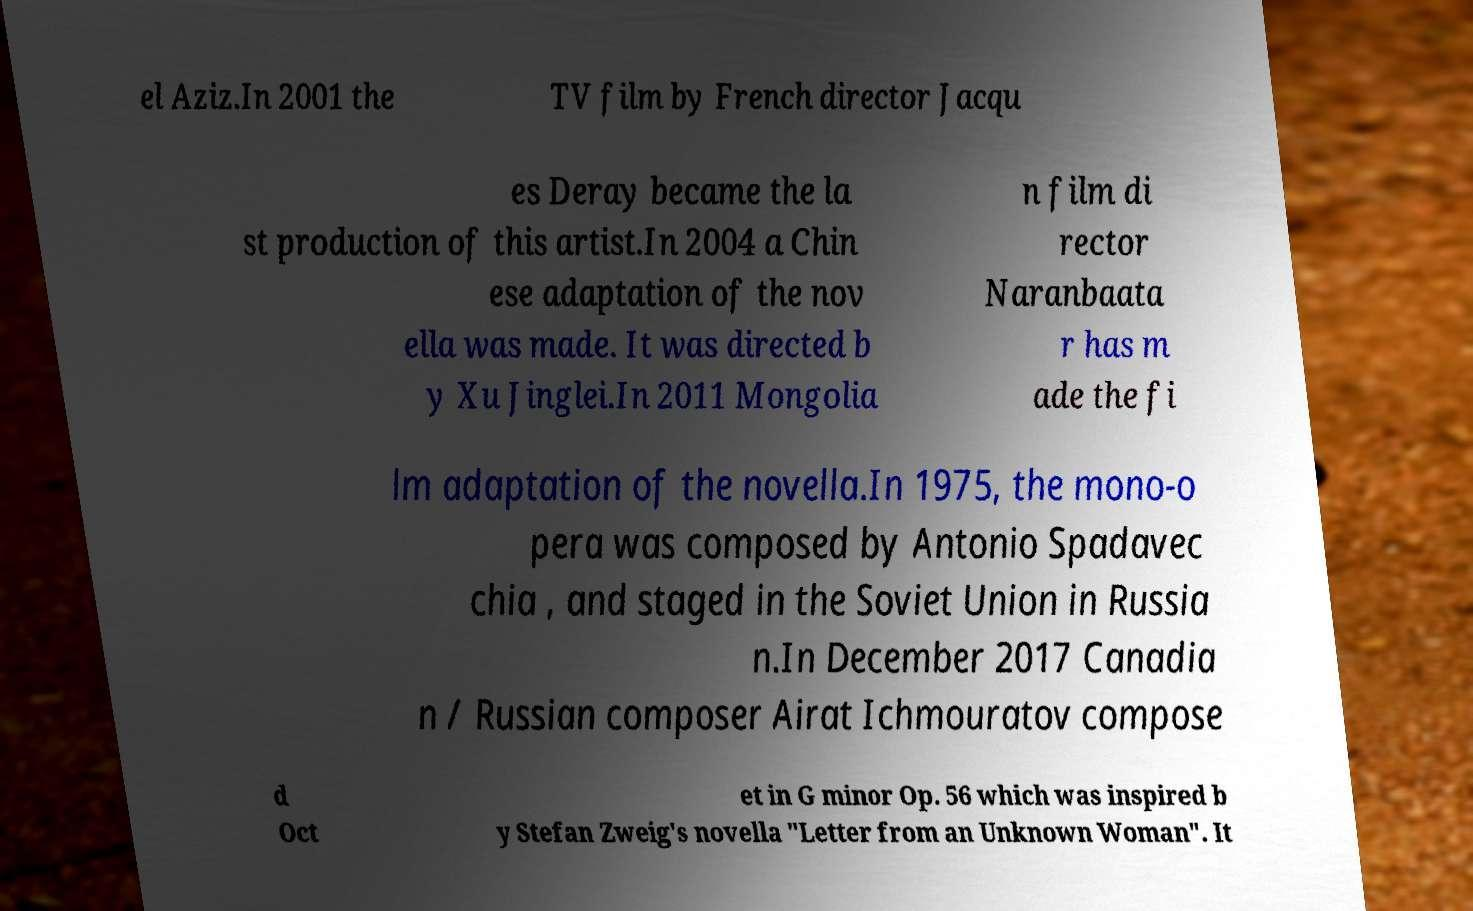Please identify and transcribe the text found in this image. el Aziz.In 2001 the TV film by French director Jacqu es Deray became the la st production of this artist.In 2004 a Chin ese adaptation of the nov ella was made. It was directed b y Xu Jinglei.In 2011 Mongolia n film di rector Naranbaata r has m ade the fi lm adaptation of the novella.In 1975, the mono-o pera was composed by Antonio Spadavec chia , and staged in the Soviet Union in Russia n.In December 2017 Canadia n / Russian composer Airat Ichmouratov compose d Oct et in G minor Op. 56 which was inspired b y Stefan Zweig's novella "Letter from an Unknown Woman". It 